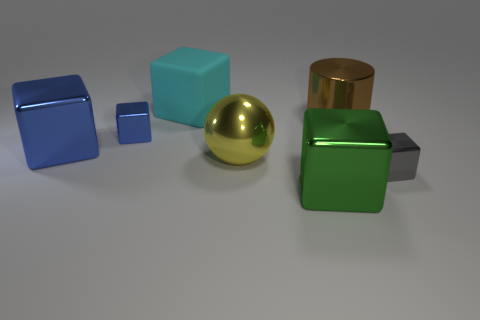Is there any pattern or arrangement to the objects? The objects are arranged with a sense of increasing size from left to right, starting with the smallest blue cube and ending with the largest grey cube. The placement doesn't seem to follow any other specific pattern. 